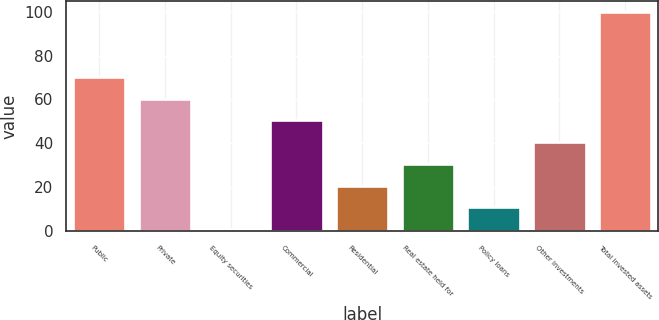Convert chart. <chart><loc_0><loc_0><loc_500><loc_500><bar_chart><fcel>Public<fcel>Private<fcel>Equity securities<fcel>Commercial<fcel>Residential<fcel>Real estate held for<fcel>Policy loans<fcel>Other investments<fcel>Total invested assets<nl><fcel>70.3<fcel>60.4<fcel>1<fcel>50.5<fcel>20.8<fcel>30.7<fcel>10.9<fcel>40.6<fcel>100<nl></chart> 